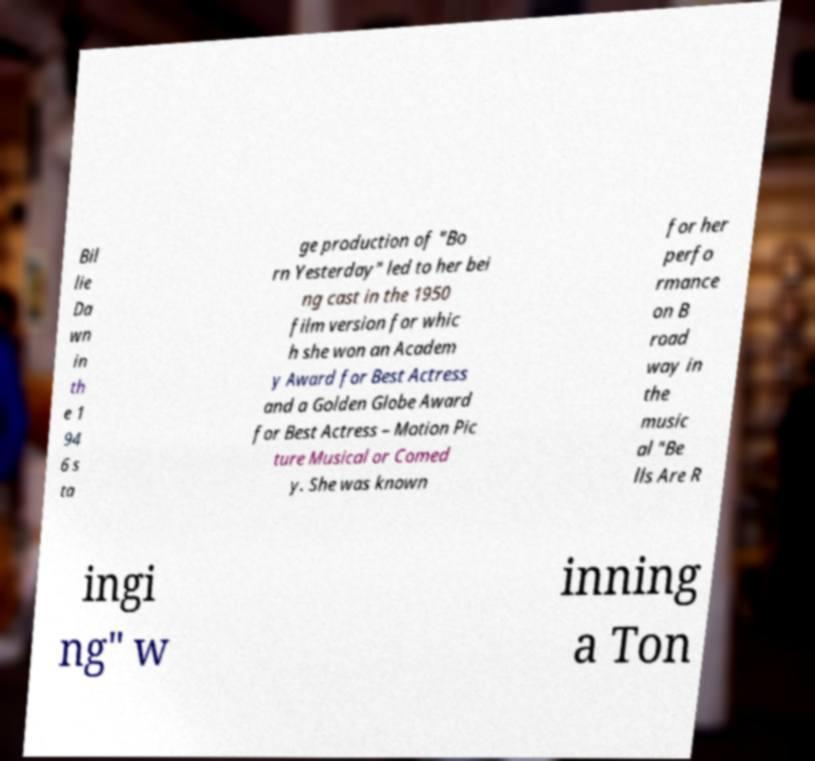What messages or text are displayed in this image? I need them in a readable, typed format. Bil lie Da wn in th e 1 94 6 s ta ge production of "Bo rn Yesterday" led to her bei ng cast in the 1950 film version for whic h she won an Academ y Award for Best Actress and a Golden Globe Award for Best Actress – Motion Pic ture Musical or Comed y. She was known for her perfo rmance on B road way in the music al "Be lls Are R ingi ng" w inning a Ton 